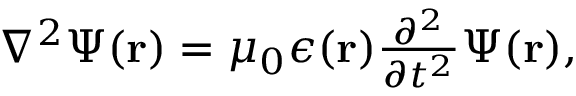Convert formula to latex. <formula><loc_0><loc_0><loc_500><loc_500>\begin{array} { r } { \nabla ^ { 2 } \Psi ( { r } ) = \mu _ { 0 } \epsilon ( { r } ) \frac { \partial ^ { 2 } } { \partial t ^ { 2 } } \Psi ( { r } ) , } \end{array}</formula> 